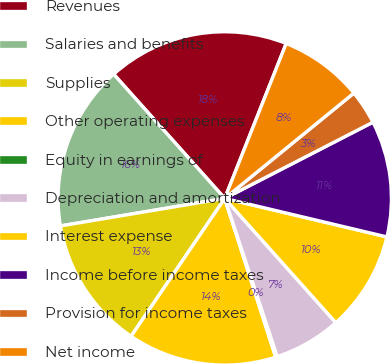<chart> <loc_0><loc_0><loc_500><loc_500><pie_chart><fcel>Revenues<fcel>Salaries and benefits<fcel>Supplies<fcel>Other operating expenses<fcel>Equity in earnings of<fcel>Depreciation and amortization<fcel>Interest expense<fcel>Income before income taxes<fcel>Provision for income taxes<fcel>Net income<nl><fcel>17.62%<fcel>16.03%<fcel>12.86%<fcel>14.44%<fcel>0.16%<fcel>6.51%<fcel>9.68%<fcel>11.27%<fcel>3.33%<fcel>8.1%<nl></chart> 